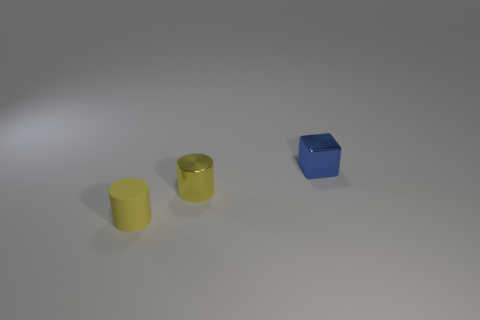Is there a thematic significance to the arrangement of these objects? The arrangement may suggest a sense of balance and simplicity. The objects are evenly spaced, creating a visual harmony and the simplicity of shapes and colors might indicate a minimalist theme. The subtle differences in texture between the cylinders also add a layer of interest to the composition, emphasizing the play of light and the tactile quality of the objects. 